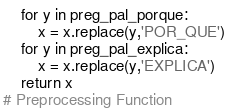<code> <loc_0><loc_0><loc_500><loc_500><_Python_>    for y in preg_pal_porque:
        x = x.replace(y,'POR_QUE')
    for y in preg_pal_explica:
        x = x.replace(y,'EXPLICA')
    return x
# Preprocessing Function</code> 